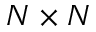Convert formula to latex. <formula><loc_0><loc_0><loc_500><loc_500>N \times N</formula> 